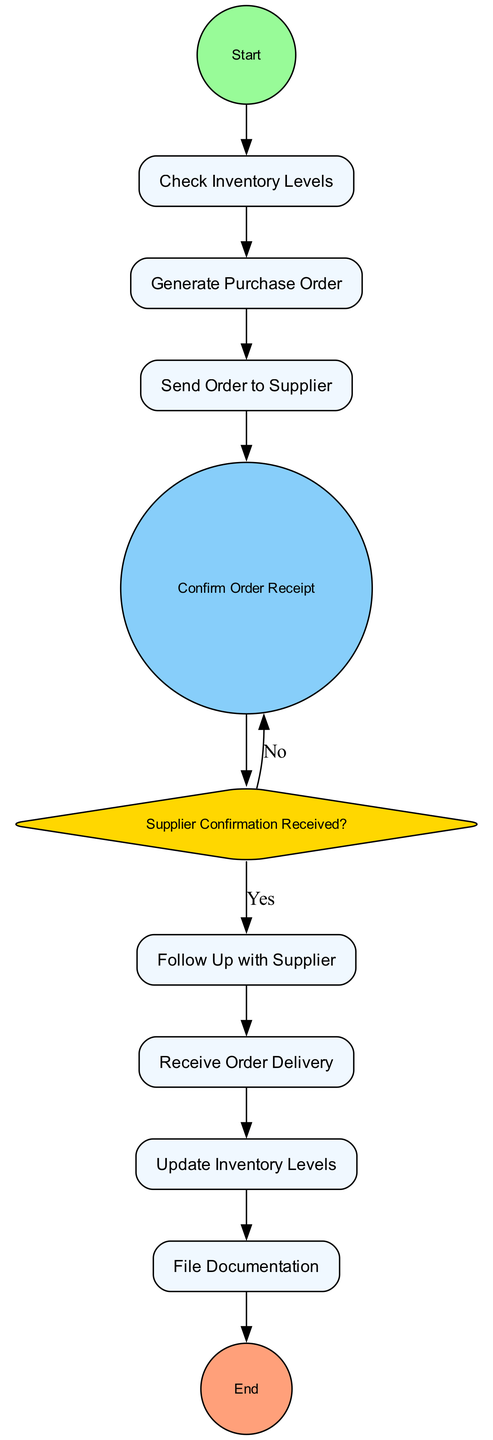What is the first task in the flowchart? The flowchart starts with the "Start" event, followed by the first task, which is "Check Inventory Levels."
Answer: Check Inventory Levels How many tasks are in the diagram? The diagram consists of 6 tasks: Check Inventory Levels, Generate Purchase Order, Send Order to Supplier, Follow Up with Supplier, Receive Order Delivery, and Update Inventory Levels.
Answer: 6 What happens if confirmation is not received from the supplier? If confirmation is not received, the flowchart indicates to "Follow Up with Supplier," which is a task that occurs after checking for supplier confirmation.
Answer: Follow Up with Supplier What is the last task before the flowchart ends? The last task before the flowchart reaches the end event is "File Documentation." This occurs after updating the inventory levels.
Answer: File Documentation How many edges connect the "Supplier Confirmation Received?" gateway? The "Supplier Confirmation Received?" gateway has 2 outgoing edges: one leading to the task if confirmation is received and another one leading to the task "Follow Up with Supplier" if confirmation is not received.
Answer: 2 What is the duration between generating a purchase order and receiving the order delivery? The flowchart shows that after generating a purchase order, it is sent to the supplier and then confirms order receipt, before finally reaching the "Receive Order Delivery" task. The exact duration is not measured specifically in the diagram, but the sequence is clear: one task follows another.
Answer: Not specified What do we do immediately after receiving the order delivery? Immediately after receiving the order delivery, the next step is to "Update Inventory Levels," which involves updating the system with the new stock levels.
Answer: Update Inventory Levels What color is the shape representing the "End" event? The shape representing the "End" event is colored light salmon, as indicated by its fill color.
Answer: Light salmon 